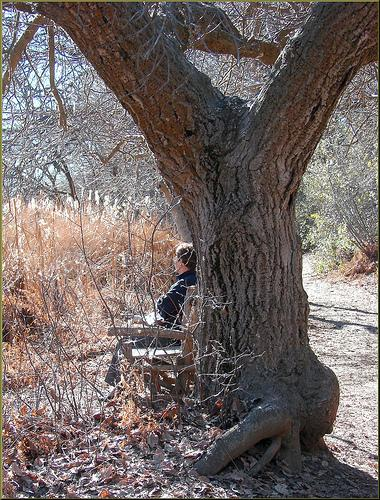What elements contribute to conveying that the scene occurs in the fall season? The fall season is conveyed through the presence of dead grass, leaves on the ground, and the bare tree. How can you describe the ground in the image? The ground is covered with dead grass, leaves, and tree roots coming out. Provide a brief explanation of the scene captured in this image, focusing on the environment. The image captures a peaceful scene in the woods during fall, with leaves on the ground, a bare tree, and a wooden bench. What is the main colors of the person's clothing? The person is wearing a blue jacket and gray pants. Identify the main object depicted in the image and describe the action it is performing. A lady sitting on a bench is the main object, and she is sitting beside a tree trunk. For the purpose of a product advertisement, describe the bench as if it was the main focus. Experience ultimate relaxation in nature with our wooden bench, featuring sturdy construction, comfortable seating, and perfect compatibility with outdoor landscapes. Clarify the surroundings of the image, mentioning at least three objects and their characteristics. The surroundings include a bare tree with wide trunk, a wooden bench with a left wooden arm, and a green bush. When referring to the person sitting on the bench, mention their physical appearance and the position they are sitting in. The person with short brown hair and eye glasses is sitting beside a tree trunk on the bench while wearing a blue jacket and gray pants. What are the prominent characteristics of the person shown in the image? The person has short brown hair, is wearing eye glasses, a blue jacket, and gray pants. Can you mention one activity of the person shown in the image? The person is sitting on a bench. 